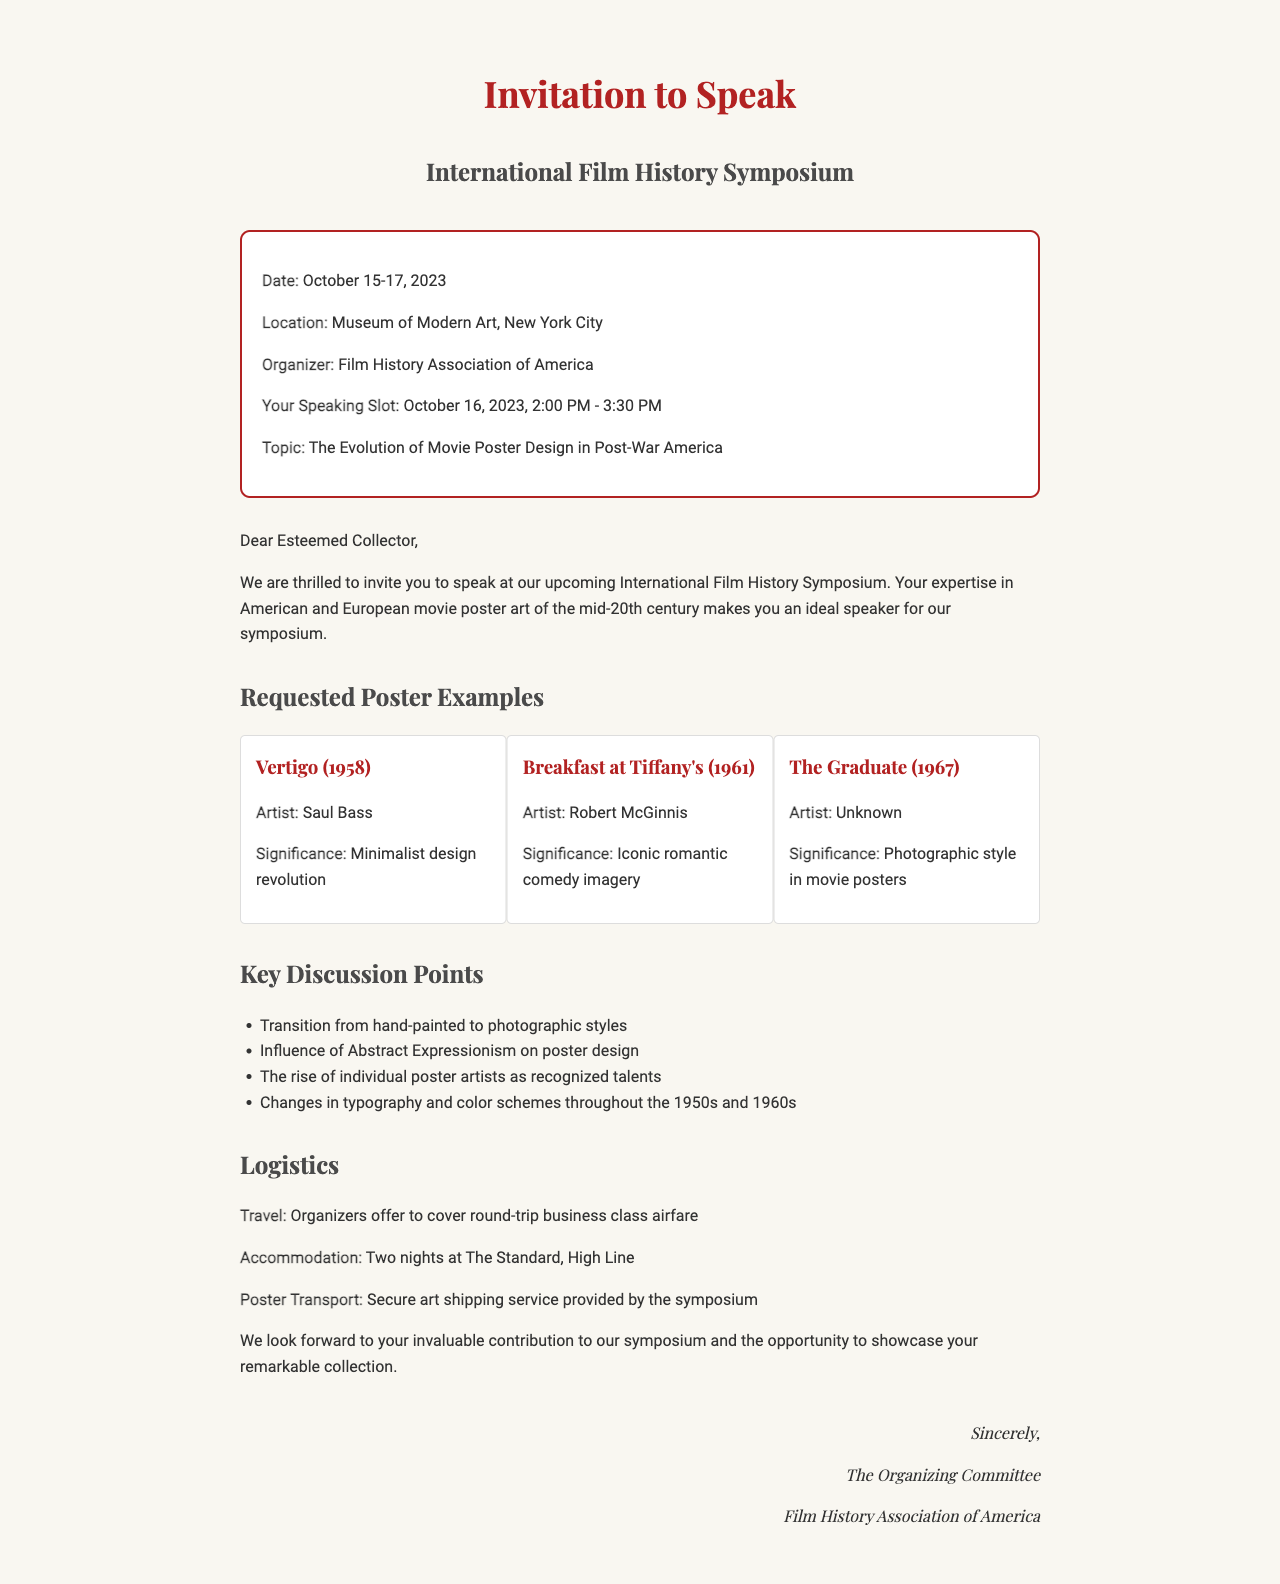what is the name of the event? The name of the event is stated in the document as the International Film History Symposium.
Answer: International Film History Symposium when is the speaker slot? The document specifies the date and time for the speaker slot as October 16, 2023, 2:00 PM - 3:30 PM.
Answer: October 16, 2023, 2:00 PM - 3:30 PM who is the artist of the poster for "Vertigo"? The document mentions that the artist of the "Vertigo" poster is Saul Bass.
Answer: Saul Bass what are the logistics for travel arrangements? The travel arrangements outlined in the document indicate that the organizers offer to cover round-trip business class airfare.
Answer: Round-trip business class airfare how long is the presentation duration? The duration of the presentation according to the document is specified as 60 minutes.
Answer: 60 minutes what is one key discussion point listed in the document? The document provides a list of key discussion points, one of which is the transition from hand-painted to photographic styles.
Answer: Transition from hand-painted to photographic styles which hotel will accommodate the speaker? The accommodation mentioned in the document is at The Standard, High Line.
Answer: The Standard, High Line who is the organizer of the event? According to the document, the organizer of the event is the Film History Association of America.
Answer: Film History Association of America 